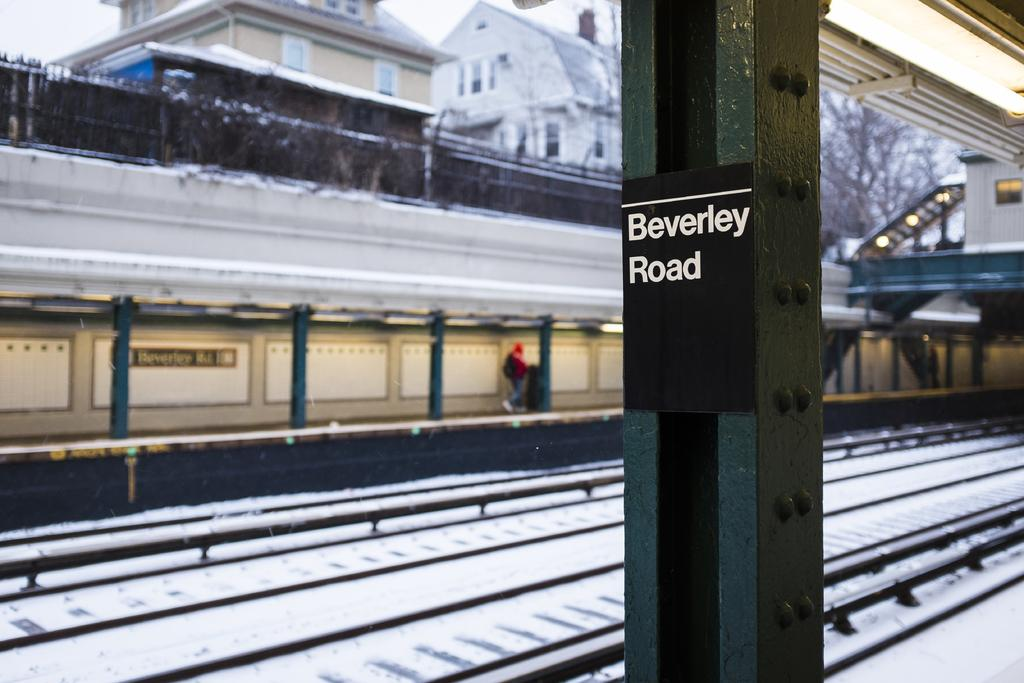What is the main feature in the image? There is a railway track in the image. Can you describe the person in the image? There is a person on a path in the image. What can be seen in the background of the image? There are buildings, lights, and trees in the background of the image. What type of nerve can be seen in the image? There is no nerve present in the image. Is the railway track on a slope in the image? The facts provided do not mention any slope, so we cannot determine if the railway track is on a slope. 